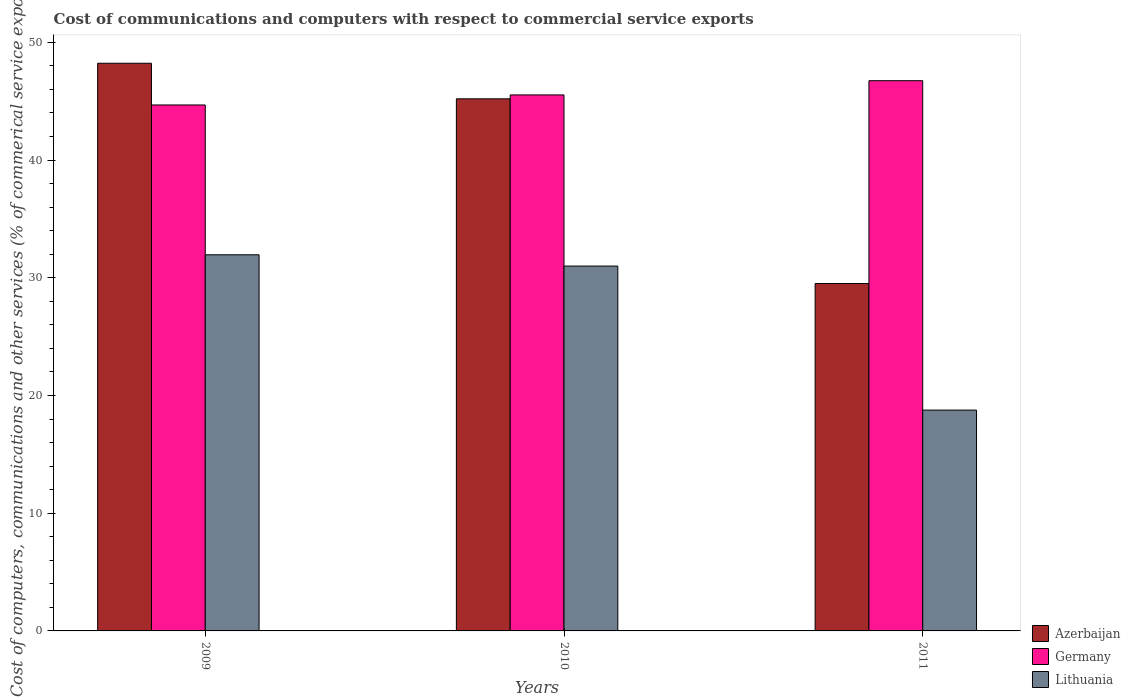How many different coloured bars are there?
Offer a very short reply. 3. Are the number of bars per tick equal to the number of legend labels?
Offer a very short reply. Yes. How many bars are there on the 3rd tick from the left?
Your answer should be very brief. 3. What is the label of the 2nd group of bars from the left?
Provide a short and direct response. 2010. What is the cost of communications and computers in Azerbaijan in 2011?
Keep it short and to the point. 29.51. Across all years, what is the maximum cost of communications and computers in Lithuania?
Ensure brevity in your answer.  31.95. Across all years, what is the minimum cost of communications and computers in Azerbaijan?
Give a very brief answer. 29.51. In which year was the cost of communications and computers in Lithuania maximum?
Give a very brief answer. 2009. What is the total cost of communications and computers in Azerbaijan in the graph?
Your response must be concise. 122.92. What is the difference between the cost of communications and computers in Lithuania in 2010 and that in 2011?
Your answer should be compact. 12.23. What is the difference between the cost of communications and computers in Azerbaijan in 2010 and the cost of communications and computers in Germany in 2009?
Give a very brief answer. 0.52. What is the average cost of communications and computers in Germany per year?
Provide a short and direct response. 45.65. In the year 2010, what is the difference between the cost of communications and computers in Azerbaijan and cost of communications and computers in Lithuania?
Give a very brief answer. 14.21. What is the ratio of the cost of communications and computers in Germany in 2009 to that in 2011?
Offer a terse response. 0.96. What is the difference between the highest and the second highest cost of communications and computers in Lithuania?
Offer a terse response. 0.96. What is the difference between the highest and the lowest cost of communications and computers in Lithuania?
Your response must be concise. 13.19. In how many years, is the cost of communications and computers in Lithuania greater than the average cost of communications and computers in Lithuania taken over all years?
Your answer should be very brief. 2. Is the sum of the cost of communications and computers in Azerbaijan in 2010 and 2011 greater than the maximum cost of communications and computers in Lithuania across all years?
Provide a succinct answer. Yes. What does the 2nd bar from the left in 2009 represents?
Your answer should be compact. Germany. What does the 2nd bar from the right in 2009 represents?
Make the answer very short. Germany. Is it the case that in every year, the sum of the cost of communications and computers in Lithuania and cost of communications and computers in Germany is greater than the cost of communications and computers in Azerbaijan?
Provide a short and direct response. Yes. How many bars are there?
Ensure brevity in your answer.  9. Are all the bars in the graph horizontal?
Offer a terse response. No. How many years are there in the graph?
Your answer should be compact. 3. Are the values on the major ticks of Y-axis written in scientific E-notation?
Give a very brief answer. No. Where does the legend appear in the graph?
Give a very brief answer. Bottom right. How are the legend labels stacked?
Your answer should be very brief. Vertical. What is the title of the graph?
Keep it short and to the point. Cost of communications and computers with respect to commercial service exports. Does "Hong Kong" appear as one of the legend labels in the graph?
Make the answer very short. No. What is the label or title of the X-axis?
Your answer should be compact. Years. What is the label or title of the Y-axis?
Offer a very short reply. Cost of computers, communications and other services (% of commerical service exports). What is the Cost of computers, communications and other services (% of commerical service exports) in Azerbaijan in 2009?
Make the answer very short. 48.22. What is the Cost of computers, communications and other services (% of commerical service exports) of Germany in 2009?
Provide a short and direct response. 44.68. What is the Cost of computers, communications and other services (% of commerical service exports) of Lithuania in 2009?
Keep it short and to the point. 31.95. What is the Cost of computers, communications and other services (% of commerical service exports) in Azerbaijan in 2010?
Ensure brevity in your answer.  45.2. What is the Cost of computers, communications and other services (% of commerical service exports) of Germany in 2010?
Provide a succinct answer. 45.53. What is the Cost of computers, communications and other services (% of commerical service exports) in Lithuania in 2010?
Provide a succinct answer. 30.99. What is the Cost of computers, communications and other services (% of commerical service exports) of Azerbaijan in 2011?
Give a very brief answer. 29.51. What is the Cost of computers, communications and other services (% of commerical service exports) in Germany in 2011?
Offer a very short reply. 46.74. What is the Cost of computers, communications and other services (% of commerical service exports) of Lithuania in 2011?
Your answer should be very brief. 18.76. Across all years, what is the maximum Cost of computers, communications and other services (% of commerical service exports) of Azerbaijan?
Your response must be concise. 48.22. Across all years, what is the maximum Cost of computers, communications and other services (% of commerical service exports) of Germany?
Make the answer very short. 46.74. Across all years, what is the maximum Cost of computers, communications and other services (% of commerical service exports) in Lithuania?
Offer a very short reply. 31.95. Across all years, what is the minimum Cost of computers, communications and other services (% of commerical service exports) in Azerbaijan?
Offer a very short reply. 29.51. Across all years, what is the minimum Cost of computers, communications and other services (% of commerical service exports) in Germany?
Offer a terse response. 44.68. Across all years, what is the minimum Cost of computers, communications and other services (% of commerical service exports) of Lithuania?
Ensure brevity in your answer.  18.76. What is the total Cost of computers, communications and other services (% of commerical service exports) of Azerbaijan in the graph?
Provide a succinct answer. 122.92. What is the total Cost of computers, communications and other services (% of commerical service exports) of Germany in the graph?
Provide a short and direct response. 136.94. What is the total Cost of computers, communications and other services (% of commerical service exports) in Lithuania in the graph?
Provide a succinct answer. 81.7. What is the difference between the Cost of computers, communications and other services (% of commerical service exports) in Azerbaijan in 2009 and that in 2010?
Offer a very short reply. 3.02. What is the difference between the Cost of computers, communications and other services (% of commerical service exports) of Germany in 2009 and that in 2010?
Make the answer very short. -0.85. What is the difference between the Cost of computers, communications and other services (% of commerical service exports) of Lithuania in 2009 and that in 2010?
Offer a very short reply. 0.96. What is the difference between the Cost of computers, communications and other services (% of commerical service exports) in Azerbaijan in 2009 and that in 2011?
Keep it short and to the point. 18.71. What is the difference between the Cost of computers, communications and other services (% of commerical service exports) of Germany in 2009 and that in 2011?
Offer a terse response. -2.06. What is the difference between the Cost of computers, communications and other services (% of commerical service exports) of Lithuania in 2009 and that in 2011?
Provide a succinct answer. 13.19. What is the difference between the Cost of computers, communications and other services (% of commerical service exports) of Azerbaijan in 2010 and that in 2011?
Offer a very short reply. 15.69. What is the difference between the Cost of computers, communications and other services (% of commerical service exports) in Germany in 2010 and that in 2011?
Keep it short and to the point. -1.21. What is the difference between the Cost of computers, communications and other services (% of commerical service exports) of Lithuania in 2010 and that in 2011?
Make the answer very short. 12.23. What is the difference between the Cost of computers, communications and other services (% of commerical service exports) in Azerbaijan in 2009 and the Cost of computers, communications and other services (% of commerical service exports) in Germany in 2010?
Ensure brevity in your answer.  2.69. What is the difference between the Cost of computers, communications and other services (% of commerical service exports) in Azerbaijan in 2009 and the Cost of computers, communications and other services (% of commerical service exports) in Lithuania in 2010?
Provide a succinct answer. 17.23. What is the difference between the Cost of computers, communications and other services (% of commerical service exports) of Germany in 2009 and the Cost of computers, communications and other services (% of commerical service exports) of Lithuania in 2010?
Keep it short and to the point. 13.68. What is the difference between the Cost of computers, communications and other services (% of commerical service exports) in Azerbaijan in 2009 and the Cost of computers, communications and other services (% of commerical service exports) in Germany in 2011?
Make the answer very short. 1.48. What is the difference between the Cost of computers, communications and other services (% of commerical service exports) of Azerbaijan in 2009 and the Cost of computers, communications and other services (% of commerical service exports) of Lithuania in 2011?
Keep it short and to the point. 29.46. What is the difference between the Cost of computers, communications and other services (% of commerical service exports) of Germany in 2009 and the Cost of computers, communications and other services (% of commerical service exports) of Lithuania in 2011?
Your answer should be compact. 25.92. What is the difference between the Cost of computers, communications and other services (% of commerical service exports) of Azerbaijan in 2010 and the Cost of computers, communications and other services (% of commerical service exports) of Germany in 2011?
Your answer should be very brief. -1.54. What is the difference between the Cost of computers, communications and other services (% of commerical service exports) in Azerbaijan in 2010 and the Cost of computers, communications and other services (% of commerical service exports) in Lithuania in 2011?
Keep it short and to the point. 26.44. What is the difference between the Cost of computers, communications and other services (% of commerical service exports) in Germany in 2010 and the Cost of computers, communications and other services (% of commerical service exports) in Lithuania in 2011?
Keep it short and to the point. 26.77. What is the average Cost of computers, communications and other services (% of commerical service exports) in Azerbaijan per year?
Provide a short and direct response. 40.97. What is the average Cost of computers, communications and other services (% of commerical service exports) of Germany per year?
Your answer should be compact. 45.65. What is the average Cost of computers, communications and other services (% of commerical service exports) of Lithuania per year?
Offer a very short reply. 27.23. In the year 2009, what is the difference between the Cost of computers, communications and other services (% of commerical service exports) of Azerbaijan and Cost of computers, communications and other services (% of commerical service exports) of Germany?
Provide a succinct answer. 3.54. In the year 2009, what is the difference between the Cost of computers, communications and other services (% of commerical service exports) of Azerbaijan and Cost of computers, communications and other services (% of commerical service exports) of Lithuania?
Give a very brief answer. 16.27. In the year 2009, what is the difference between the Cost of computers, communications and other services (% of commerical service exports) in Germany and Cost of computers, communications and other services (% of commerical service exports) in Lithuania?
Ensure brevity in your answer.  12.73. In the year 2010, what is the difference between the Cost of computers, communications and other services (% of commerical service exports) in Azerbaijan and Cost of computers, communications and other services (% of commerical service exports) in Germany?
Make the answer very short. -0.33. In the year 2010, what is the difference between the Cost of computers, communications and other services (% of commerical service exports) in Azerbaijan and Cost of computers, communications and other services (% of commerical service exports) in Lithuania?
Give a very brief answer. 14.21. In the year 2010, what is the difference between the Cost of computers, communications and other services (% of commerical service exports) of Germany and Cost of computers, communications and other services (% of commerical service exports) of Lithuania?
Offer a very short reply. 14.54. In the year 2011, what is the difference between the Cost of computers, communications and other services (% of commerical service exports) in Azerbaijan and Cost of computers, communications and other services (% of commerical service exports) in Germany?
Your answer should be very brief. -17.23. In the year 2011, what is the difference between the Cost of computers, communications and other services (% of commerical service exports) in Azerbaijan and Cost of computers, communications and other services (% of commerical service exports) in Lithuania?
Keep it short and to the point. 10.75. In the year 2011, what is the difference between the Cost of computers, communications and other services (% of commerical service exports) in Germany and Cost of computers, communications and other services (% of commerical service exports) in Lithuania?
Ensure brevity in your answer.  27.98. What is the ratio of the Cost of computers, communications and other services (% of commerical service exports) in Azerbaijan in 2009 to that in 2010?
Your response must be concise. 1.07. What is the ratio of the Cost of computers, communications and other services (% of commerical service exports) in Germany in 2009 to that in 2010?
Give a very brief answer. 0.98. What is the ratio of the Cost of computers, communications and other services (% of commerical service exports) in Lithuania in 2009 to that in 2010?
Ensure brevity in your answer.  1.03. What is the ratio of the Cost of computers, communications and other services (% of commerical service exports) of Azerbaijan in 2009 to that in 2011?
Make the answer very short. 1.63. What is the ratio of the Cost of computers, communications and other services (% of commerical service exports) in Germany in 2009 to that in 2011?
Your answer should be compact. 0.96. What is the ratio of the Cost of computers, communications and other services (% of commerical service exports) of Lithuania in 2009 to that in 2011?
Make the answer very short. 1.7. What is the ratio of the Cost of computers, communications and other services (% of commerical service exports) in Azerbaijan in 2010 to that in 2011?
Ensure brevity in your answer.  1.53. What is the ratio of the Cost of computers, communications and other services (% of commerical service exports) in Germany in 2010 to that in 2011?
Provide a short and direct response. 0.97. What is the ratio of the Cost of computers, communications and other services (% of commerical service exports) in Lithuania in 2010 to that in 2011?
Make the answer very short. 1.65. What is the difference between the highest and the second highest Cost of computers, communications and other services (% of commerical service exports) in Azerbaijan?
Provide a short and direct response. 3.02. What is the difference between the highest and the second highest Cost of computers, communications and other services (% of commerical service exports) in Germany?
Give a very brief answer. 1.21. What is the difference between the highest and the second highest Cost of computers, communications and other services (% of commerical service exports) in Lithuania?
Provide a short and direct response. 0.96. What is the difference between the highest and the lowest Cost of computers, communications and other services (% of commerical service exports) in Azerbaijan?
Keep it short and to the point. 18.71. What is the difference between the highest and the lowest Cost of computers, communications and other services (% of commerical service exports) in Germany?
Make the answer very short. 2.06. What is the difference between the highest and the lowest Cost of computers, communications and other services (% of commerical service exports) of Lithuania?
Ensure brevity in your answer.  13.19. 